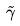Convert formula to latex. <formula><loc_0><loc_0><loc_500><loc_500>\tilde { \gamma }</formula> 